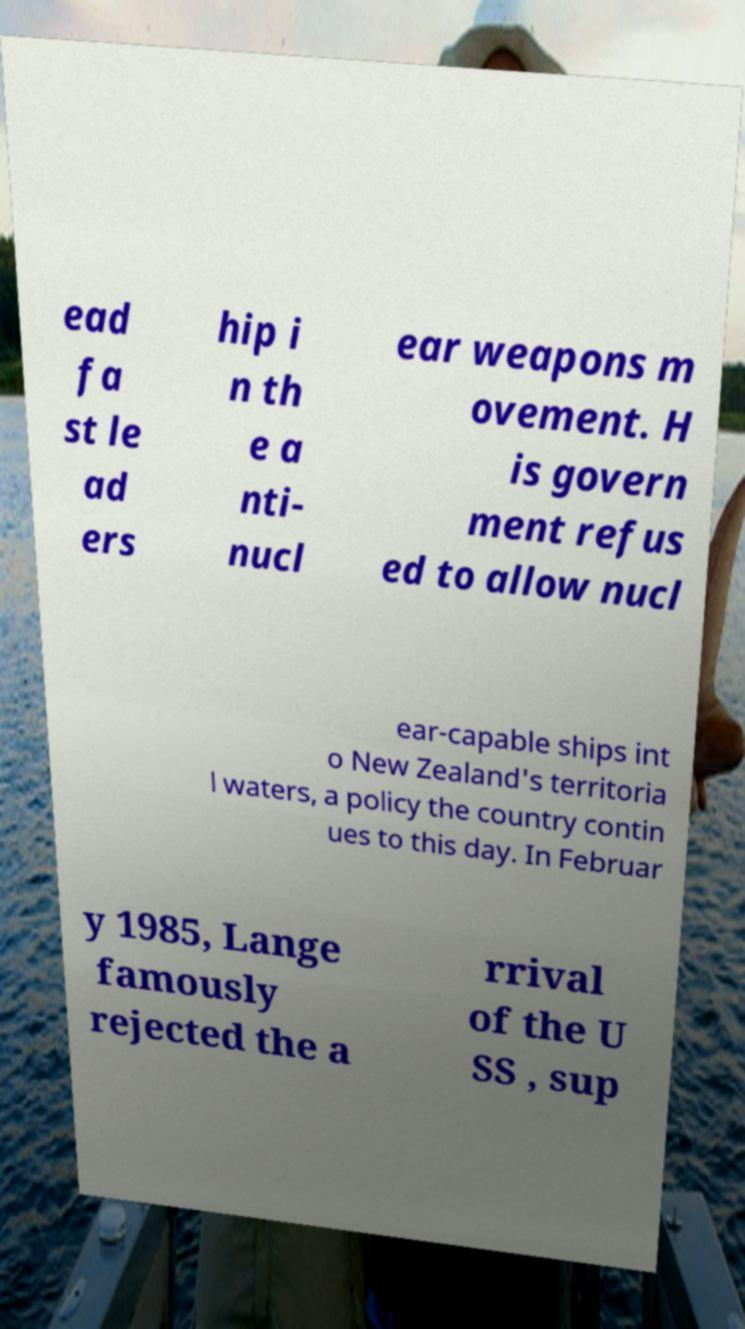There's text embedded in this image that I need extracted. Can you transcribe it verbatim? ead fa st le ad ers hip i n th e a nti- nucl ear weapons m ovement. H is govern ment refus ed to allow nucl ear-capable ships int o New Zealand's territoria l waters, a policy the country contin ues to this day. In Februar y 1985, Lange famously rejected the a rrival of the U SS , sup 